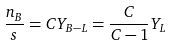Convert formula to latex. <formula><loc_0><loc_0><loc_500><loc_500>\frac { n _ { B } } { s } = C Y _ { B - L } = \frac { C } { C - 1 } Y _ { L }</formula> 